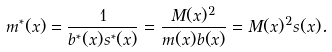Convert formula to latex. <formula><loc_0><loc_0><loc_500><loc_500>m ^ { * } ( x ) = \frac { 1 } { b ^ { * } ( x ) s ^ { * } ( x ) } = \frac { M ( x ) ^ { 2 } } { m ( x ) b ( x ) } = M ( x ) ^ { 2 } s ( x ) .</formula> 